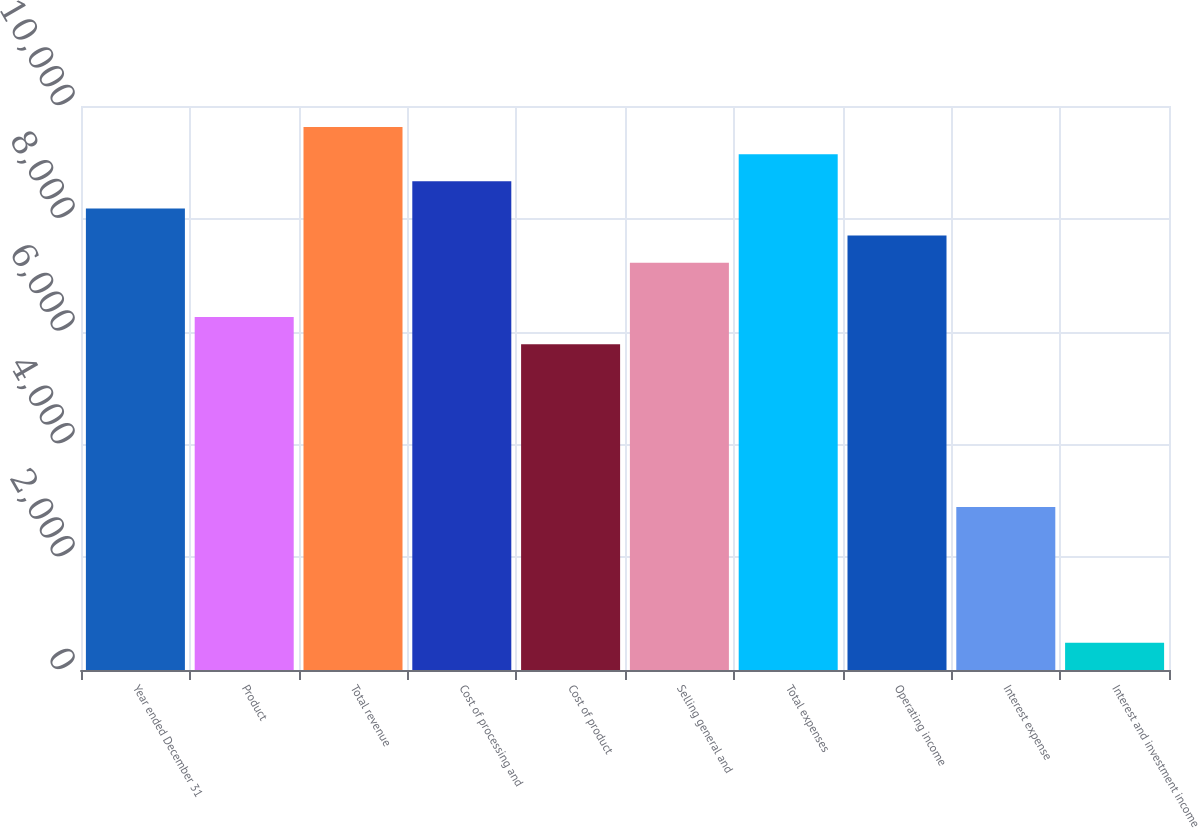<chart> <loc_0><loc_0><loc_500><loc_500><bar_chart><fcel>Year ended December 31<fcel>Product<fcel>Total revenue<fcel>Cost of processing and<fcel>Cost of product<fcel>Selling general and<fcel>Total expenses<fcel>Operating income<fcel>Interest expense<fcel>Interest and investment income<nl><fcel>8183.81<fcel>6258.21<fcel>9628.01<fcel>8665.21<fcel>5776.81<fcel>7221.01<fcel>9146.61<fcel>7702.41<fcel>2888.41<fcel>481.41<nl></chart> 